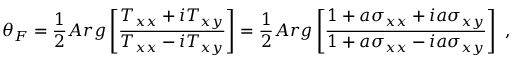<formula> <loc_0><loc_0><loc_500><loc_500>\theta _ { F } = \frac { 1 } { 2 } A r g \left [ \frac { T _ { x x } + i T _ { x y } } { T _ { x x } - i T _ { x y } } \right ] = \frac { 1 } { 2 } A r g \left [ \frac { 1 + a \sigma _ { x x } + i a \sigma _ { x y } } { 1 + a \sigma _ { x x } - i a \sigma _ { x y } } \right ] \ ,</formula> 